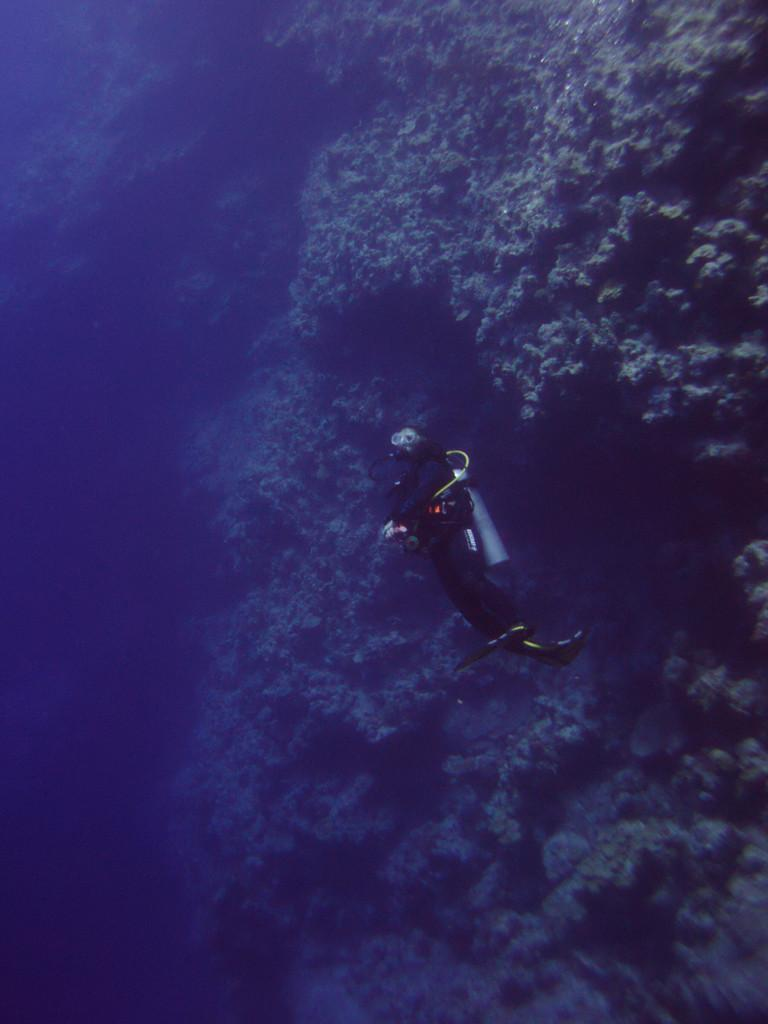Where was the image taken? The image is taken underwater. What activity is the person in the image engaged in? The person is performing scuba diving in the image. What can be seen in the water behind the person? Marine plants are visible in the water behind the person. What letters can be seen on the scuba diving equipment in the image? There are no visible letters on the scuba diving equipment in the image. What is the limit of the person's scuba diving abilities in the image? The image does not provide information about the person's scuba diving abilities or limitations. 